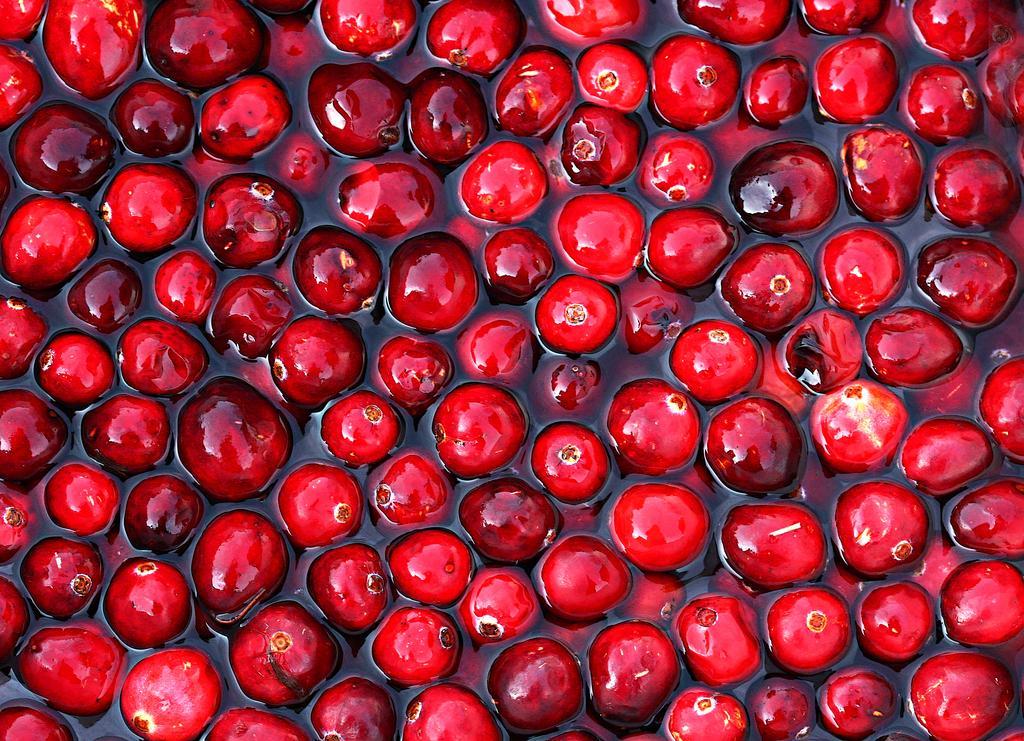Could you give a brief overview of what you see in this image? In this picture we can see fruits in the water. 